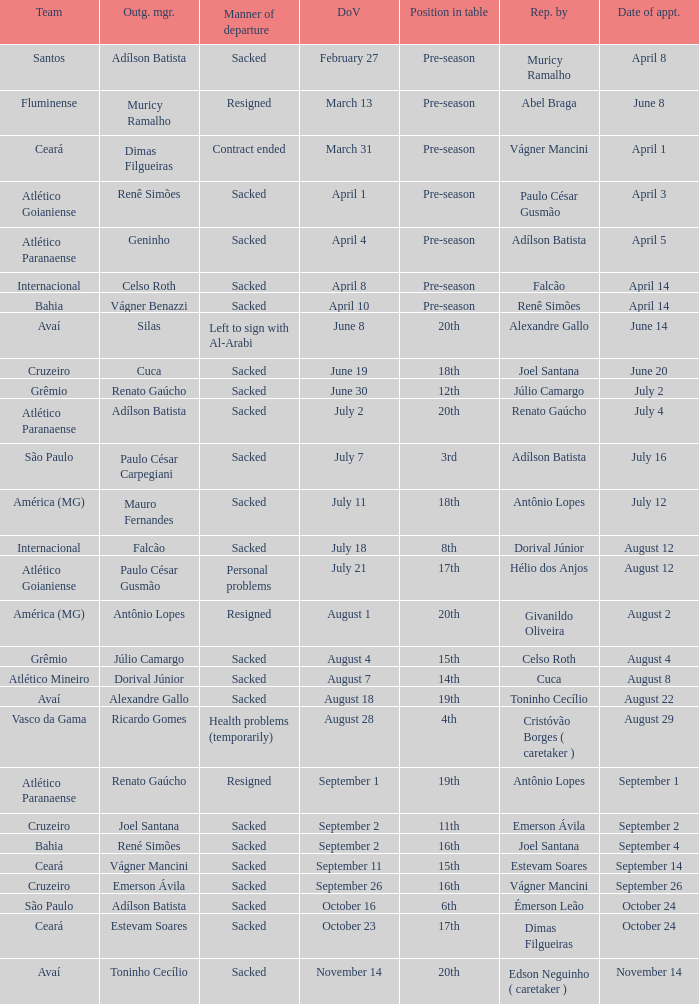Why did Geninho leave as manager? Sacked. 